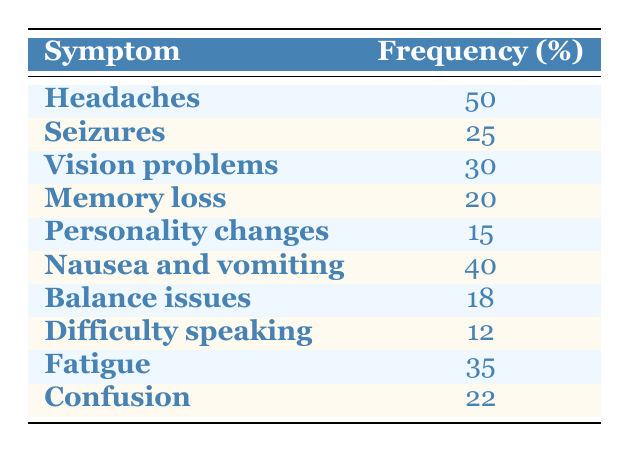What is the most common symptom of brain tumors according to the table? The table shows the frequency of various symptoms. "Headaches" is listed with a frequency of 50%, which is the highest among all symptoms.
Answer: Headaches What percentage of patients experience nausea and vomiting? The table indicates that "Nausea and vomiting" has a frequency of 40%. This value is directly given in the table.
Answer: 40% Is memory loss a more common symptom than difficulty speaking? The table lists "Memory loss" at 20% and "Difficulty speaking" at 12%. Since 20% is greater than 12%, memory loss is indeed more common.
Answer: Yes What is the total frequency percentage of all symptoms listed? To find the total frequency percentage, sum all the percentages: 50 + 25 + 30 + 20 + 15 + 40 + 18 + 12 + 35 + 22 =  287. Therefore, the total frequency percentage is 287%.
Answer: 287% How many symptoms have a frequency of 20% or more? From the table, the symptoms with 20% or more are: Headaches (50%), Nausea and vomiting (40%), Vision problems (30%), Fatigue (35%), Confusion (22%), Seizures (25%), and Memory loss (20%). Counting these gives us 7 symptoms.
Answer: 7 What symptom has the lowest frequency percentage? The lowest frequency percentage from the table is "Difficulty speaking," which is listed at 12%, making it the least common symptom.
Answer: Difficulty speaking What is the difference in percentage between the most common symptom and the least common symptom? The most common symptom is "Headaches" at 50%, and the least common is "Difficulty speaking" at 12%. The difference is calculated as 50 - 12 = 38%.
Answer: 38% Which symptoms have a frequency greater than 20% but less than 30%? According to the table, the symptoms fitting this criteria are "Vision problems" at 30% and "Fatigue" at 35%, but "Vision problems" is exactly 30%, hence the one that meets the condition is "Fatigue" at 35%. Therefore, there are no symptoms between 20% and 30%.
Answer: None 